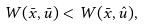Convert formula to latex. <formula><loc_0><loc_0><loc_500><loc_500>W ( \bar { x } , \bar { u } ) < W ( \bar { x } , \hat { u } ) ,</formula> 